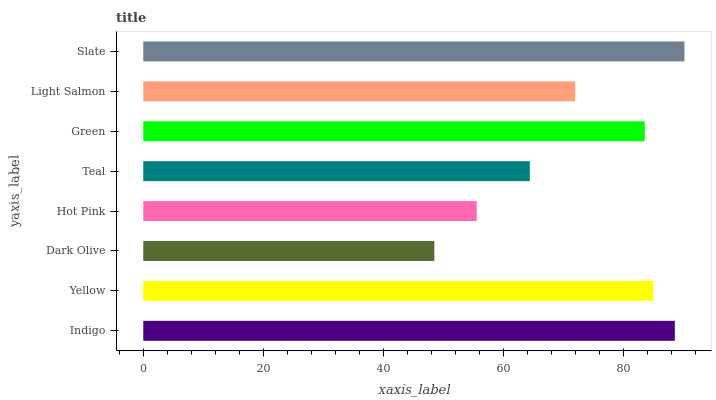Is Dark Olive the minimum?
Answer yes or no. Yes. Is Slate the maximum?
Answer yes or no. Yes. Is Yellow the minimum?
Answer yes or no. No. Is Yellow the maximum?
Answer yes or no. No. Is Indigo greater than Yellow?
Answer yes or no. Yes. Is Yellow less than Indigo?
Answer yes or no. Yes. Is Yellow greater than Indigo?
Answer yes or no. No. Is Indigo less than Yellow?
Answer yes or no. No. Is Green the high median?
Answer yes or no. Yes. Is Light Salmon the low median?
Answer yes or no. Yes. Is Slate the high median?
Answer yes or no. No. Is Slate the low median?
Answer yes or no. No. 